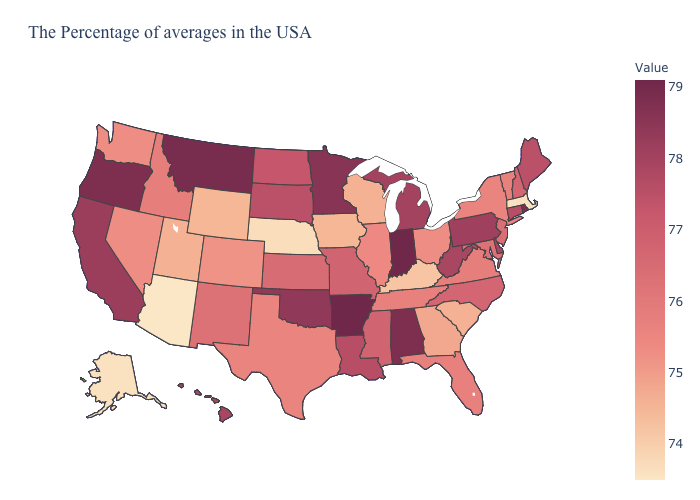Is the legend a continuous bar?
Short answer required. Yes. Among the states that border Indiana , which have the lowest value?
Give a very brief answer. Kentucky. Does Kentucky have the lowest value in the South?
Answer briefly. Yes. Which states have the lowest value in the USA?
Answer briefly. Arizona. Which states hav the highest value in the Northeast?
Quick response, please. Rhode Island. Does Oregon have the lowest value in the West?
Short answer required. No. Does the map have missing data?
Quick response, please. No. Does Arizona have the lowest value in the USA?
Quick response, please. Yes. Does Wyoming have a lower value than Nebraska?
Answer briefly. No. 